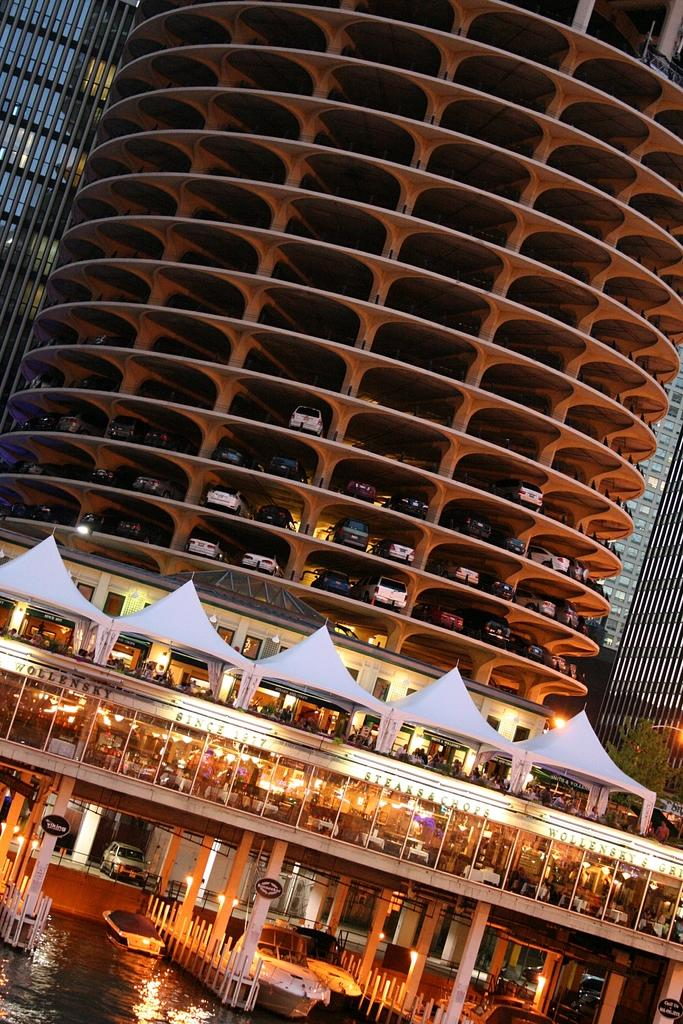What type of structures are visible in the image? There are buildings in the image. What are the people doing under the tents in the image? The people are under tents in the image. What can be seen on the water in the image? There are boats on the water in the image. What type of vehicles are parked in the image? There are cars parked in the image. Where is the jail located in the image? There is no jail present in the image. What type of badge is being worn by the people under the tents? There is no badge visible in the image. 